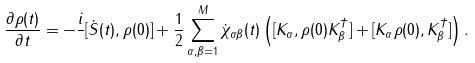<formula> <loc_0><loc_0><loc_500><loc_500>\frac { \partial \rho ( t ) } { \partial t } = - { \frac { i } { } } [ \dot { S } ( t ) , \rho ( 0 ) ] + { \frac { 1 } { 2 } } \sum _ { \alpha , \beta = 1 } ^ { M } \dot { \chi } _ { \alpha \beta } ( t ) \left ( [ { K } _ { \alpha } , \rho ( 0 ) { K } _ { \beta } ^ { \dagger } ] + [ { K } _ { \alpha } \rho ( 0 ) , { K } _ { \beta } ^ { \dagger } ] \right ) .</formula> 